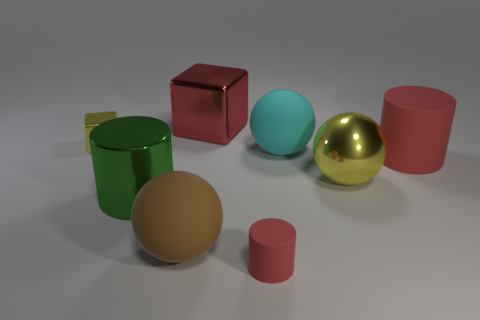Subtract all blue blocks. How many red cylinders are left? 2 Subtract all matte balls. How many balls are left? 1 Add 1 tiny yellow things. How many objects exist? 9 Subtract all spheres. How many objects are left? 5 Subtract all large rubber things. Subtract all big red rubber cylinders. How many objects are left? 4 Add 6 brown balls. How many brown balls are left? 7 Add 3 blue metal cylinders. How many blue metal cylinders exist? 3 Subtract 1 yellow cubes. How many objects are left? 7 